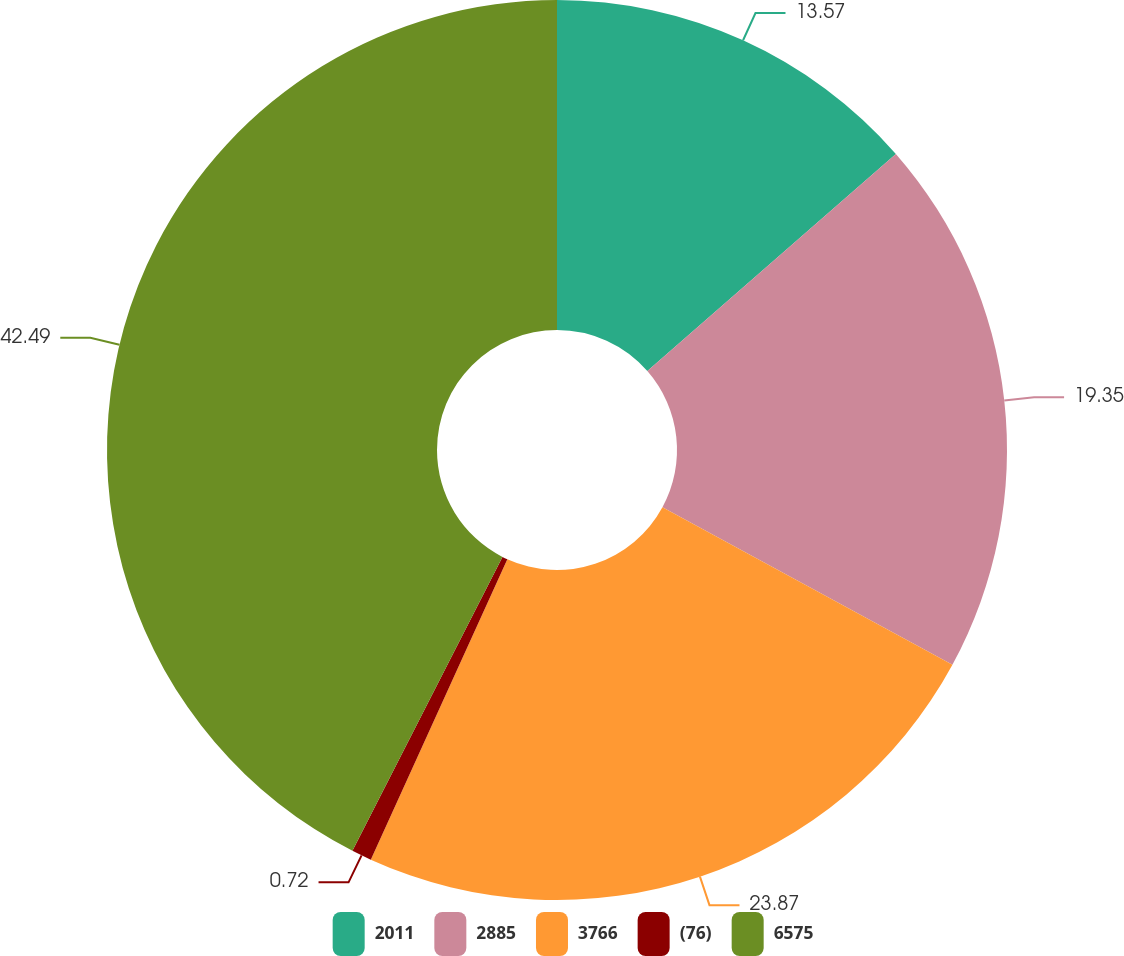Convert chart to OTSL. <chart><loc_0><loc_0><loc_500><loc_500><pie_chart><fcel>2011<fcel>2885<fcel>3766<fcel>(76)<fcel>6575<nl><fcel>13.57%<fcel>19.35%<fcel>23.87%<fcel>0.72%<fcel>42.49%<nl></chart> 